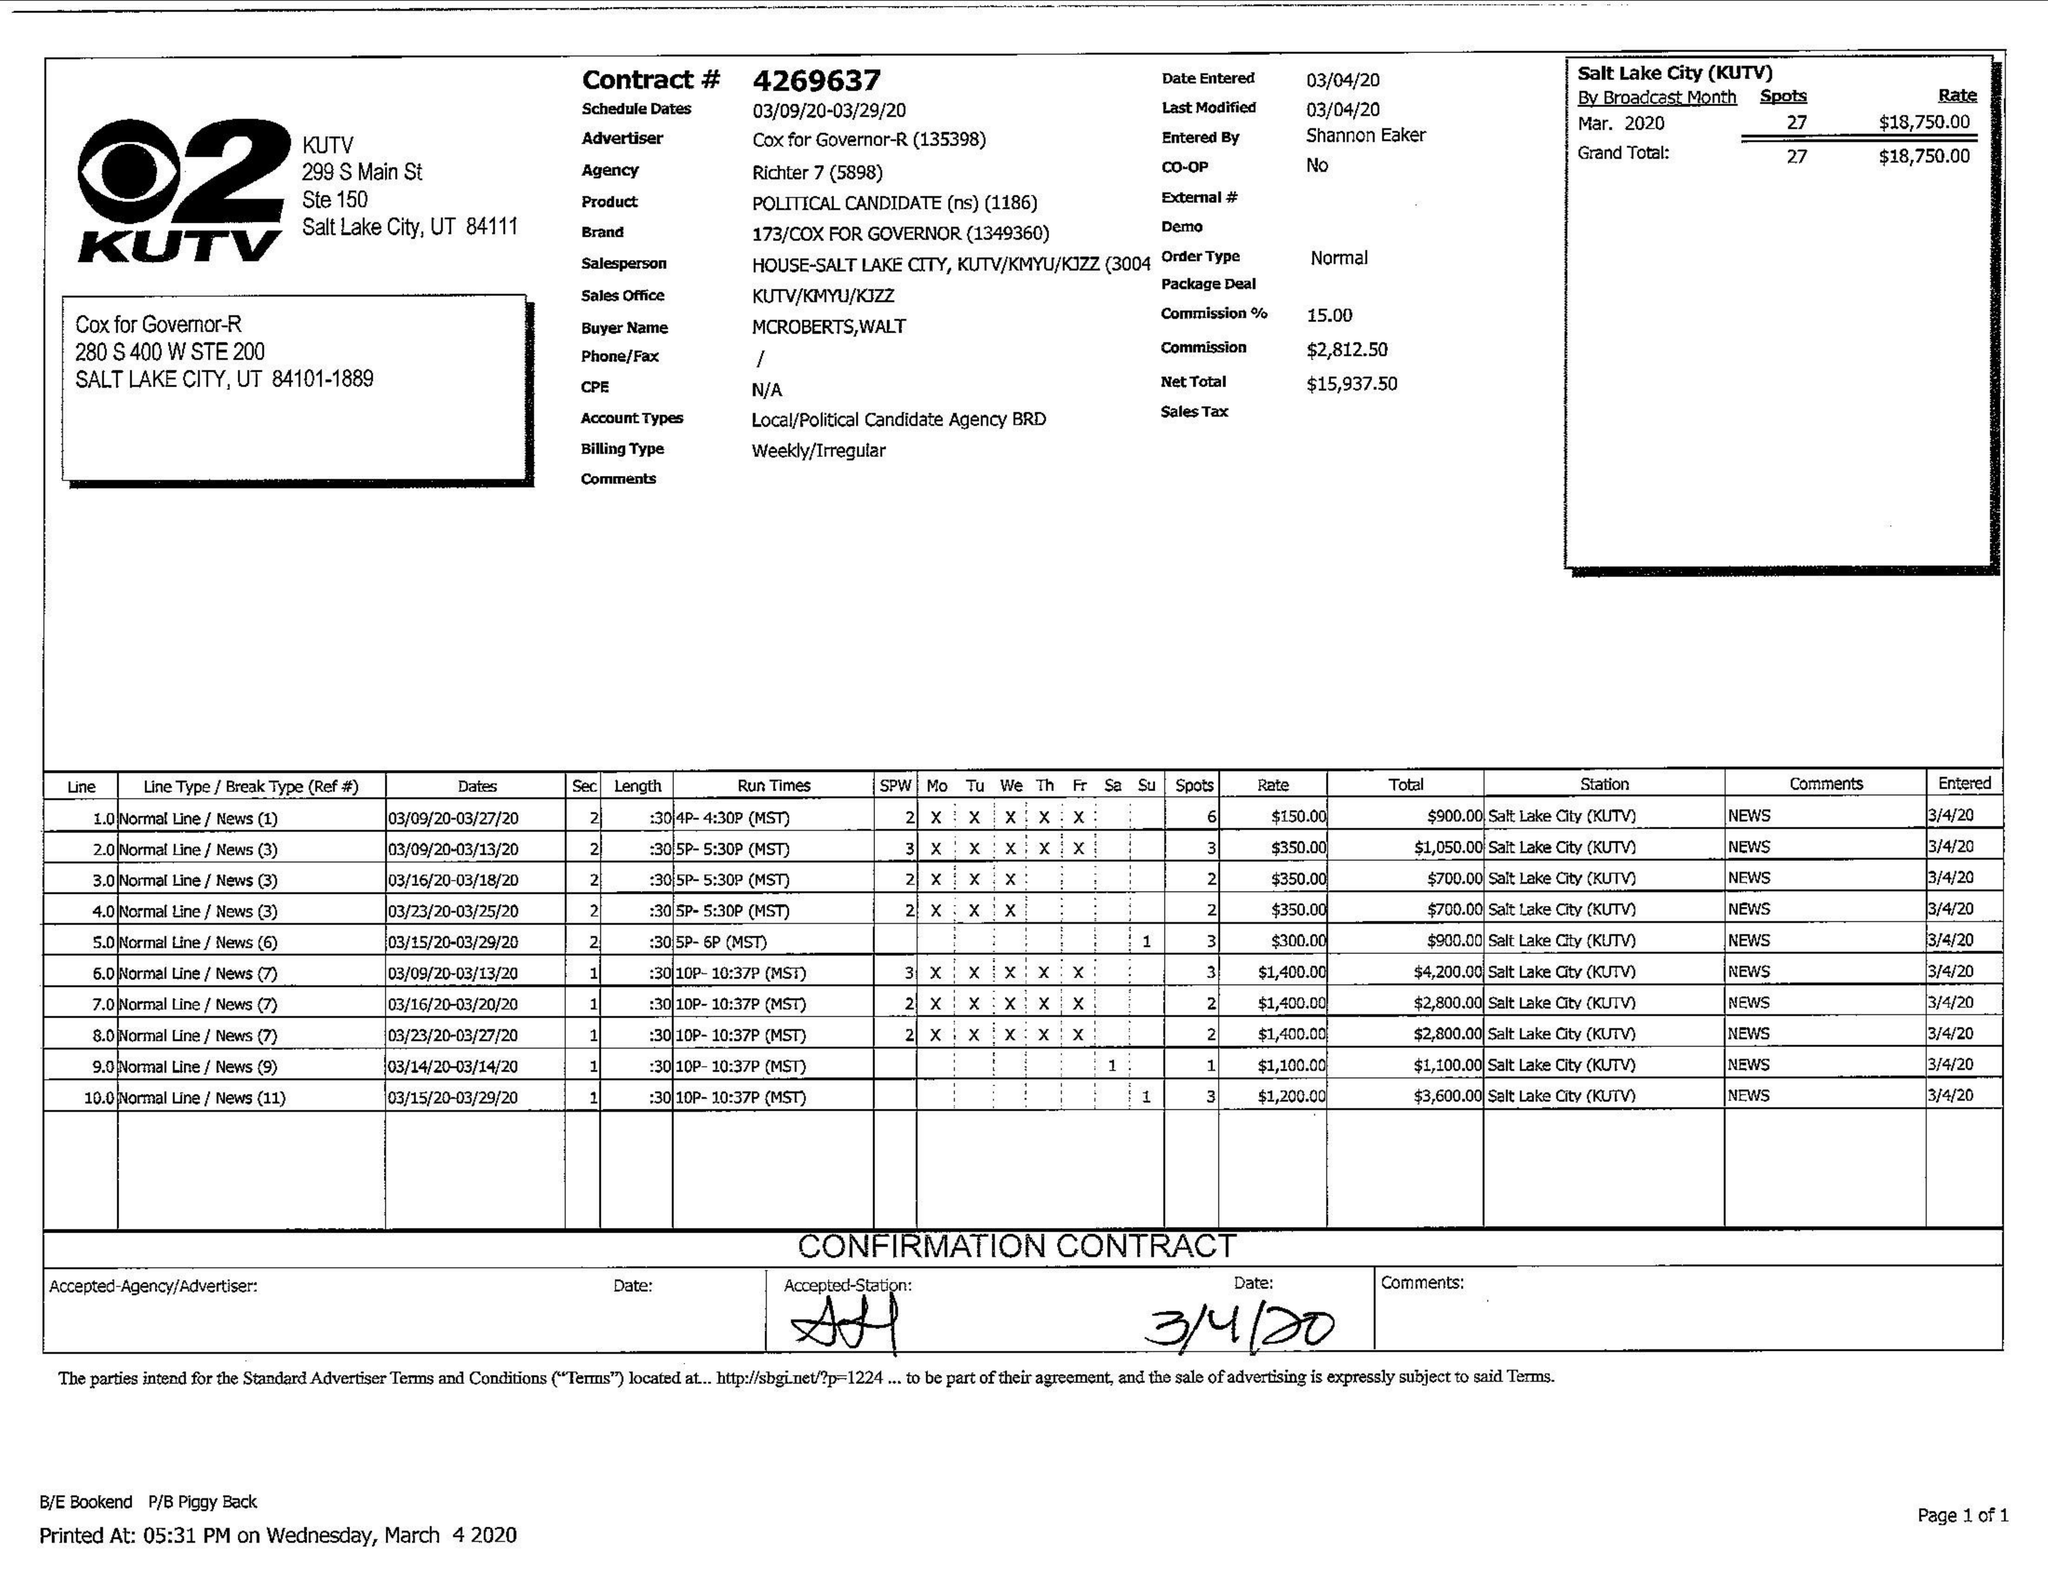What is the value for the flight_from?
Answer the question using a single word or phrase. 03/09/20 